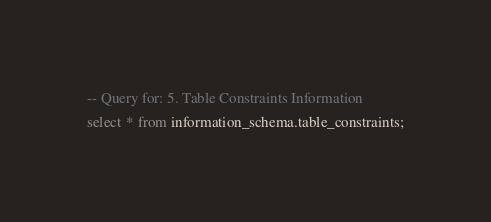Convert code to text. <code><loc_0><loc_0><loc_500><loc_500><_SQL_>-- Query for: 5. Table Constraints Information
select * from information_schema.table_constraints;

</code> 